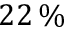<formula> <loc_0><loc_0><loc_500><loc_500>2 2 \, \%</formula> 